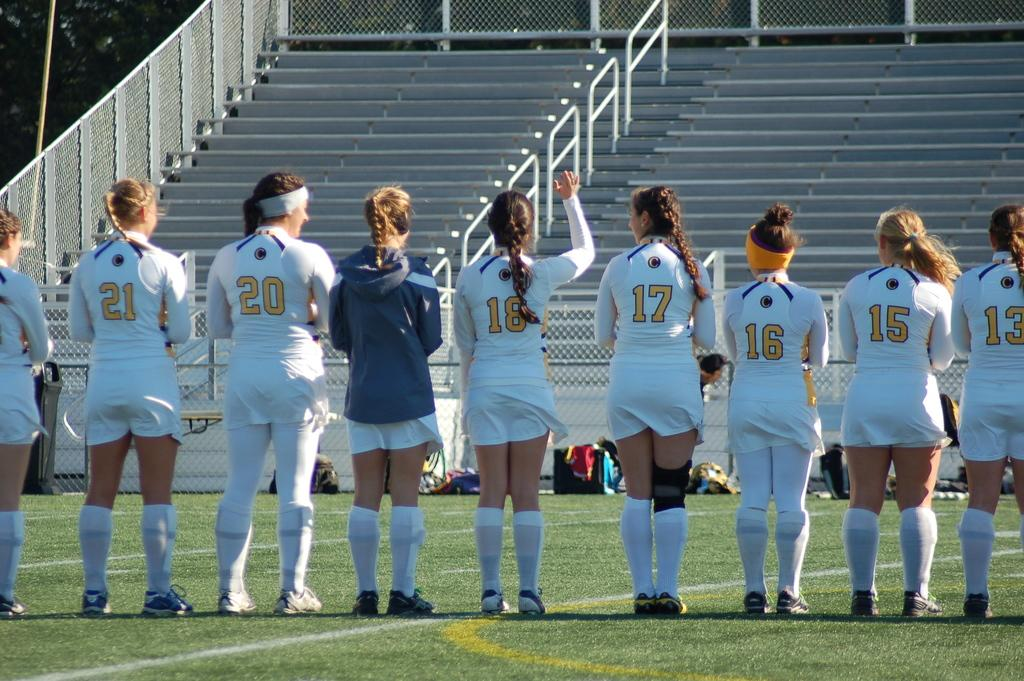<image>
Render a clear and concise summary of the photo. Soccer players line up on the field with number 13 to the far right. 